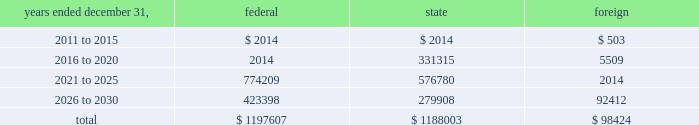American tower corporation and subsidiaries notes to consolidated financial statements the valuation allowance increased from $ 47.8 million as of december 31 , 2009 to $ 48.2 million as of december 31 , 2010 .
The increase was primarily due to valuation allowances on foreign loss carryforwards .
At december 31 , 2010 , the company has provided a valuation allowance of approximately $ 48.2 million which primarily relates to state net operating loss carryforwards , equity investments and foreign items .
The company has not provided a valuation allowance for the remaining deferred tax assets , primarily its federal net operating loss carryforwards , as management believes the company will have sufficient taxable income to realize these federal net operating loss carryforwards during the twenty-year tax carryforward period .
Valuation allowances may be reversed if related deferred tax assets are deemed realizable based on changes in facts and circumstances relevant to the assets 2019 recoverability .
The recoverability of the company 2019s remaining net deferred tax asset has been assessed utilizing projections based on its current operations .
The projections show a significant decrease in depreciation in the later years of the carryforward period as a result of a significant portion of its assets being fully depreciated during the first fifteen years of the carryforward period .
Accordingly , the recoverability of the net deferred tax asset is not dependent on material improvements to operations , material asset sales or other non-routine transactions .
Based on its current outlook of future taxable income during the carryforward period , management believes that the net deferred tax asset will be realized .
The company 2019s deferred tax assets as of december 31 , 2010 and 2009 in the table above do not include $ 122.1 million and $ 113.9 million , respectively , of excess tax benefits from the exercises of employee stock options that are a component of net operating losses .
Total stockholders 2019 equity as of december 31 , 2010 will be increased by $ 122.1 million if and when any such excess tax benefits are ultimately realized .
At december 31 , 2010 , the company had net federal and state operating loss carryforwards available to reduce future federal and state taxable income of approximately $ 1.2 billion , including losses related to employee stock options of $ 0.3 billion .
If not utilized , the company 2019s net operating loss carryforwards expire as follows ( in thousands ) : .
In addition , the company has mexican tax credits of $ 5.2 million which if not utilized would expire in 2017. .
At december 2010 what was the percent of the losses related to employee stock options included in the net federal operating loss carry forwards? 
Computations: (0.3 / 1.2)
Answer: 0.25. 